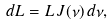<formula> <loc_0><loc_0><loc_500><loc_500>d L = L \, J ( \nu ) \, d \nu ,</formula> 